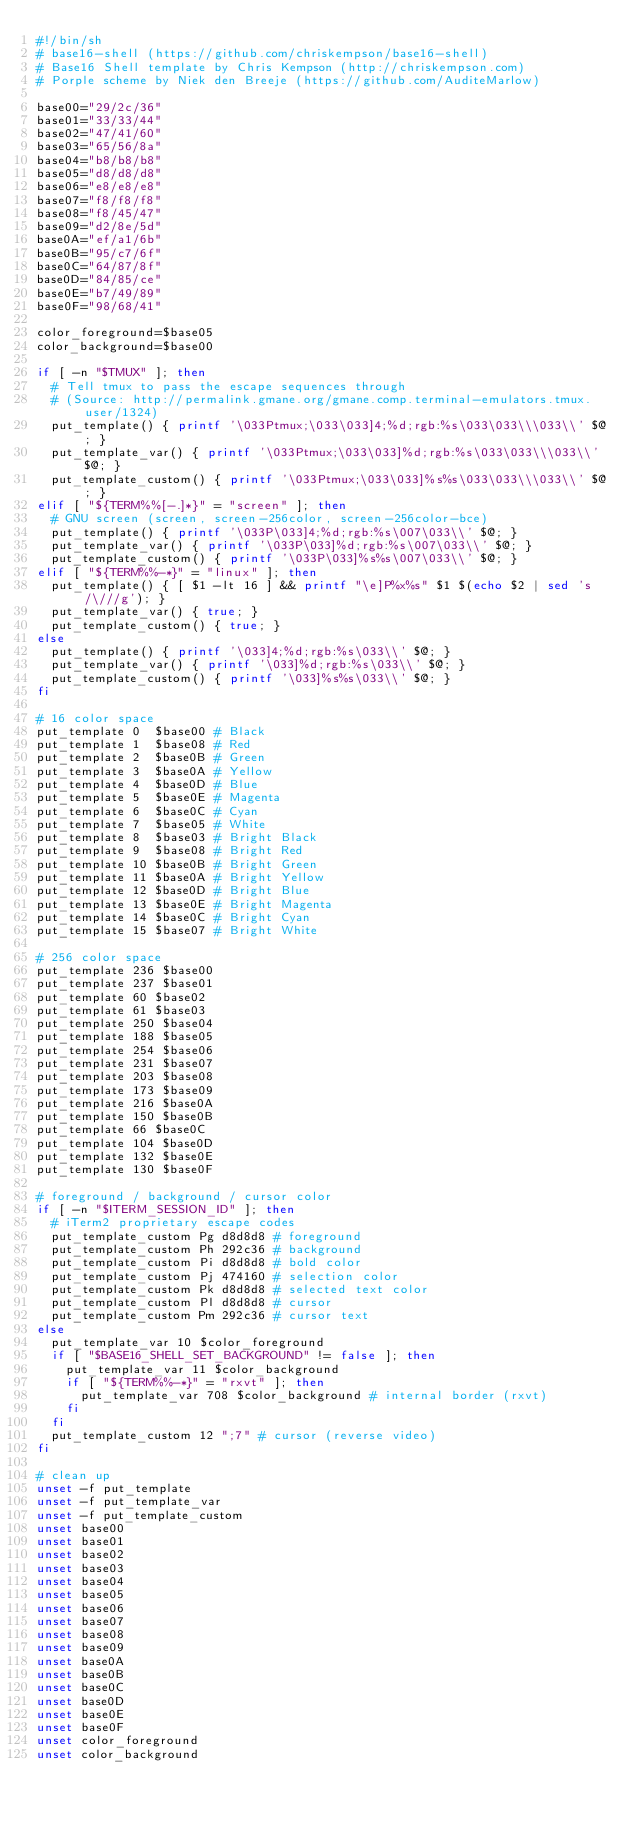Convert code to text. <code><loc_0><loc_0><loc_500><loc_500><_Bash_>#!/bin/sh
# base16-shell (https://github.com/chriskempson/base16-shell)
# Base16 Shell template by Chris Kempson (http://chriskempson.com)
# Porple scheme by Niek den Breeje (https://github.com/AuditeMarlow)

base00="29/2c/36"
base01="33/33/44"
base02="47/41/60"
base03="65/56/8a"
base04="b8/b8/b8"
base05="d8/d8/d8"
base06="e8/e8/e8"
base07="f8/f8/f8"
base08="f8/45/47"
base09="d2/8e/5d"
base0A="ef/a1/6b"
base0B="95/c7/6f"
base0C="64/87/8f"
base0D="84/85/ce"
base0E="b7/49/89"
base0F="98/68/41"

color_foreground=$base05
color_background=$base00

if [ -n "$TMUX" ]; then
  # Tell tmux to pass the escape sequences through
  # (Source: http://permalink.gmane.org/gmane.comp.terminal-emulators.tmux.user/1324)
  put_template() { printf '\033Ptmux;\033\033]4;%d;rgb:%s\033\033\\\033\\' $@; }
  put_template_var() { printf '\033Ptmux;\033\033]%d;rgb:%s\033\033\\\033\\' $@; }
  put_template_custom() { printf '\033Ptmux;\033\033]%s%s\033\033\\\033\\' $@; }
elif [ "${TERM%%[-.]*}" = "screen" ]; then
  # GNU screen (screen, screen-256color, screen-256color-bce)
  put_template() { printf '\033P\033]4;%d;rgb:%s\007\033\\' $@; }
  put_template_var() { printf '\033P\033]%d;rgb:%s\007\033\\' $@; }
  put_template_custom() { printf '\033P\033]%s%s\007\033\\' $@; }
elif [ "${TERM%%-*}" = "linux" ]; then
  put_template() { [ $1 -lt 16 ] && printf "\e]P%x%s" $1 $(echo $2 | sed 's/\///g'); }
  put_template_var() { true; }
  put_template_custom() { true; }
else
  put_template() { printf '\033]4;%d;rgb:%s\033\\' $@; }
  put_template_var() { printf '\033]%d;rgb:%s\033\\' $@; }
  put_template_custom() { printf '\033]%s%s\033\\' $@; }
fi

# 16 color space
put_template 0  $base00 # Black
put_template 1  $base08 # Red
put_template 2  $base0B # Green
put_template 3  $base0A # Yellow
put_template 4  $base0D # Blue
put_template 5  $base0E # Magenta
put_template 6  $base0C # Cyan
put_template 7  $base05 # White
put_template 8  $base03 # Bright Black
put_template 9  $base08 # Bright Red
put_template 10 $base0B # Bright Green
put_template 11 $base0A # Bright Yellow
put_template 12 $base0D # Bright Blue
put_template 13 $base0E # Bright Magenta
put_template 14 $base0C # Bright Cyan
put_template 15 $base07 # Bright White

# 256 color space
put_template 236 $base00
put_template 237 $base01
put_template 60 $base02
put_template 61 $base03
put_template 250 $base04
put_template 188 $base05
put_template 254 $base06
put_template 231 $base07
put_template 203 $base08
put_template 173 $base09
put_template 216 $base0A
put_template 150 $base0B
put_template 66 $base0C
put_template 104 $base0D
put_template 132 $base0E
put_template 130 $base0F

# foreground / background / cursor color
if [ -n "$ITERM_SESSION_ID" ]; then
  # iTerm2 proprietary escape codes
  put_template_custom Pg d8d8d8 # foreground
  put_template_custom Ph 292c36 # background
  put_template_custom Pi d8d8d8 # bold color
  put_template_custom Pj 474160 # selection color
  put_template_custom Pk d8d8d8 # selected text color
  put_template_custom Pl d8d8d8 # cursor
  put_template_custom Pm 292c36 # cursor text
else
  put_template_var 10 $color_foreground
  if [ "$BASE16_SHELL_SET_BACKGROUND" != false ]; then
    put_template_var 11 $color_background
    if [ "${TERM%%-*}" = "rxvt" ]; then
      put_template_var 708 $color_background # internal border (rxvt)
    fi
  fi
  put_template_custom 12 ";7" # cursor (reverse video)
fi

# clean up
unset -f put_template
unset -f put_template_var
unset -f put_template_custom
unset base00
unset base01
unset base02
unset base03
unset base04
unset base05
unset base06
unset base07
unset base08
unset base09
unset base0A
unset base0B
unset base0C
unset base0D
unset base0E
unset base0F
unset color_foreground
unset color_background
</code> 